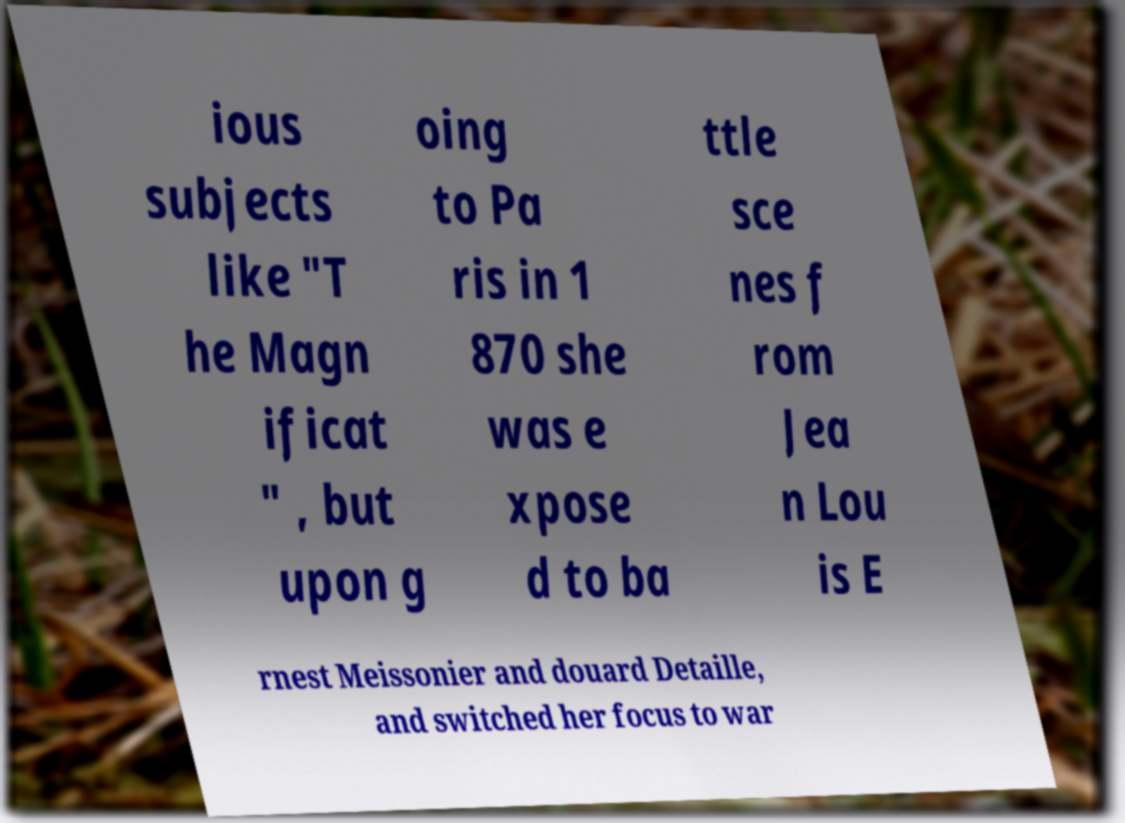There's text embedded in this image that I need extracted. Can you transcribe it verbatim? ious subjects like "T he Magn ificat " , but upon g oing to Pa ris in 1 870 she was e xpose d to ba ttle sce nes f rom Jea n Lou is E rnest Meissonier and douard Detaille, and switched her focus to war 